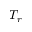<formula> <loc_0><loc_0><loc_500><loc_500>T _ { r }</formula> 